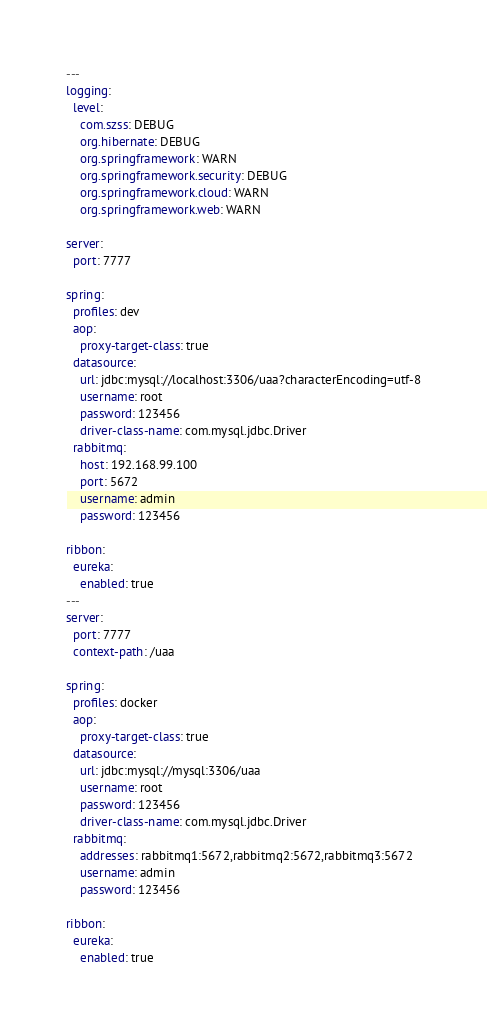Convert code to text. <code><loc_0><loc_0><loc_500><loc_500><_YAML_>---
logging:
  level:
    com.szss: DEBUG
    org.hibernate: DEBUG
    org.springframework: WARN
    org.springframework.security: DEBUG
    org.springframework.cloud: WARN
    org.springframework.web: WARN

server:
  port: 7777

spring:
  profiles: dev
  aop:
    proxy-target-class: true
  datasource:
    url: jdbc:mysql://localhost:3306/uaa?characterEncoding=utf-8
    username: root
    password: 123456
    driver-class-name: com.mysql.jdbc.Driver
  rabbitmq:
    host: 192.168.99.100
    port: 5672
    username: admin
    password: 123456

ribbon:
  eureka:
    enabled: true
---
server:
  port: 7777
  context-path: /uaa

spring:
  profiles: docker
  aop:
    proxy-target-class: true
  datasource:
    url: jdbc:mysql://mysql:3306/uaa
    username: root
    password: 123456
    driver-class-name: com.mysql.jdbc.Driver
  rabbitmq:
    addresses: rabbitmq1:5672,rabbitmq2:5672,rabbitmq3:5672
    username: admin
    password: 123456

ribbon:
  eureka:
    enabled: true
</code> 